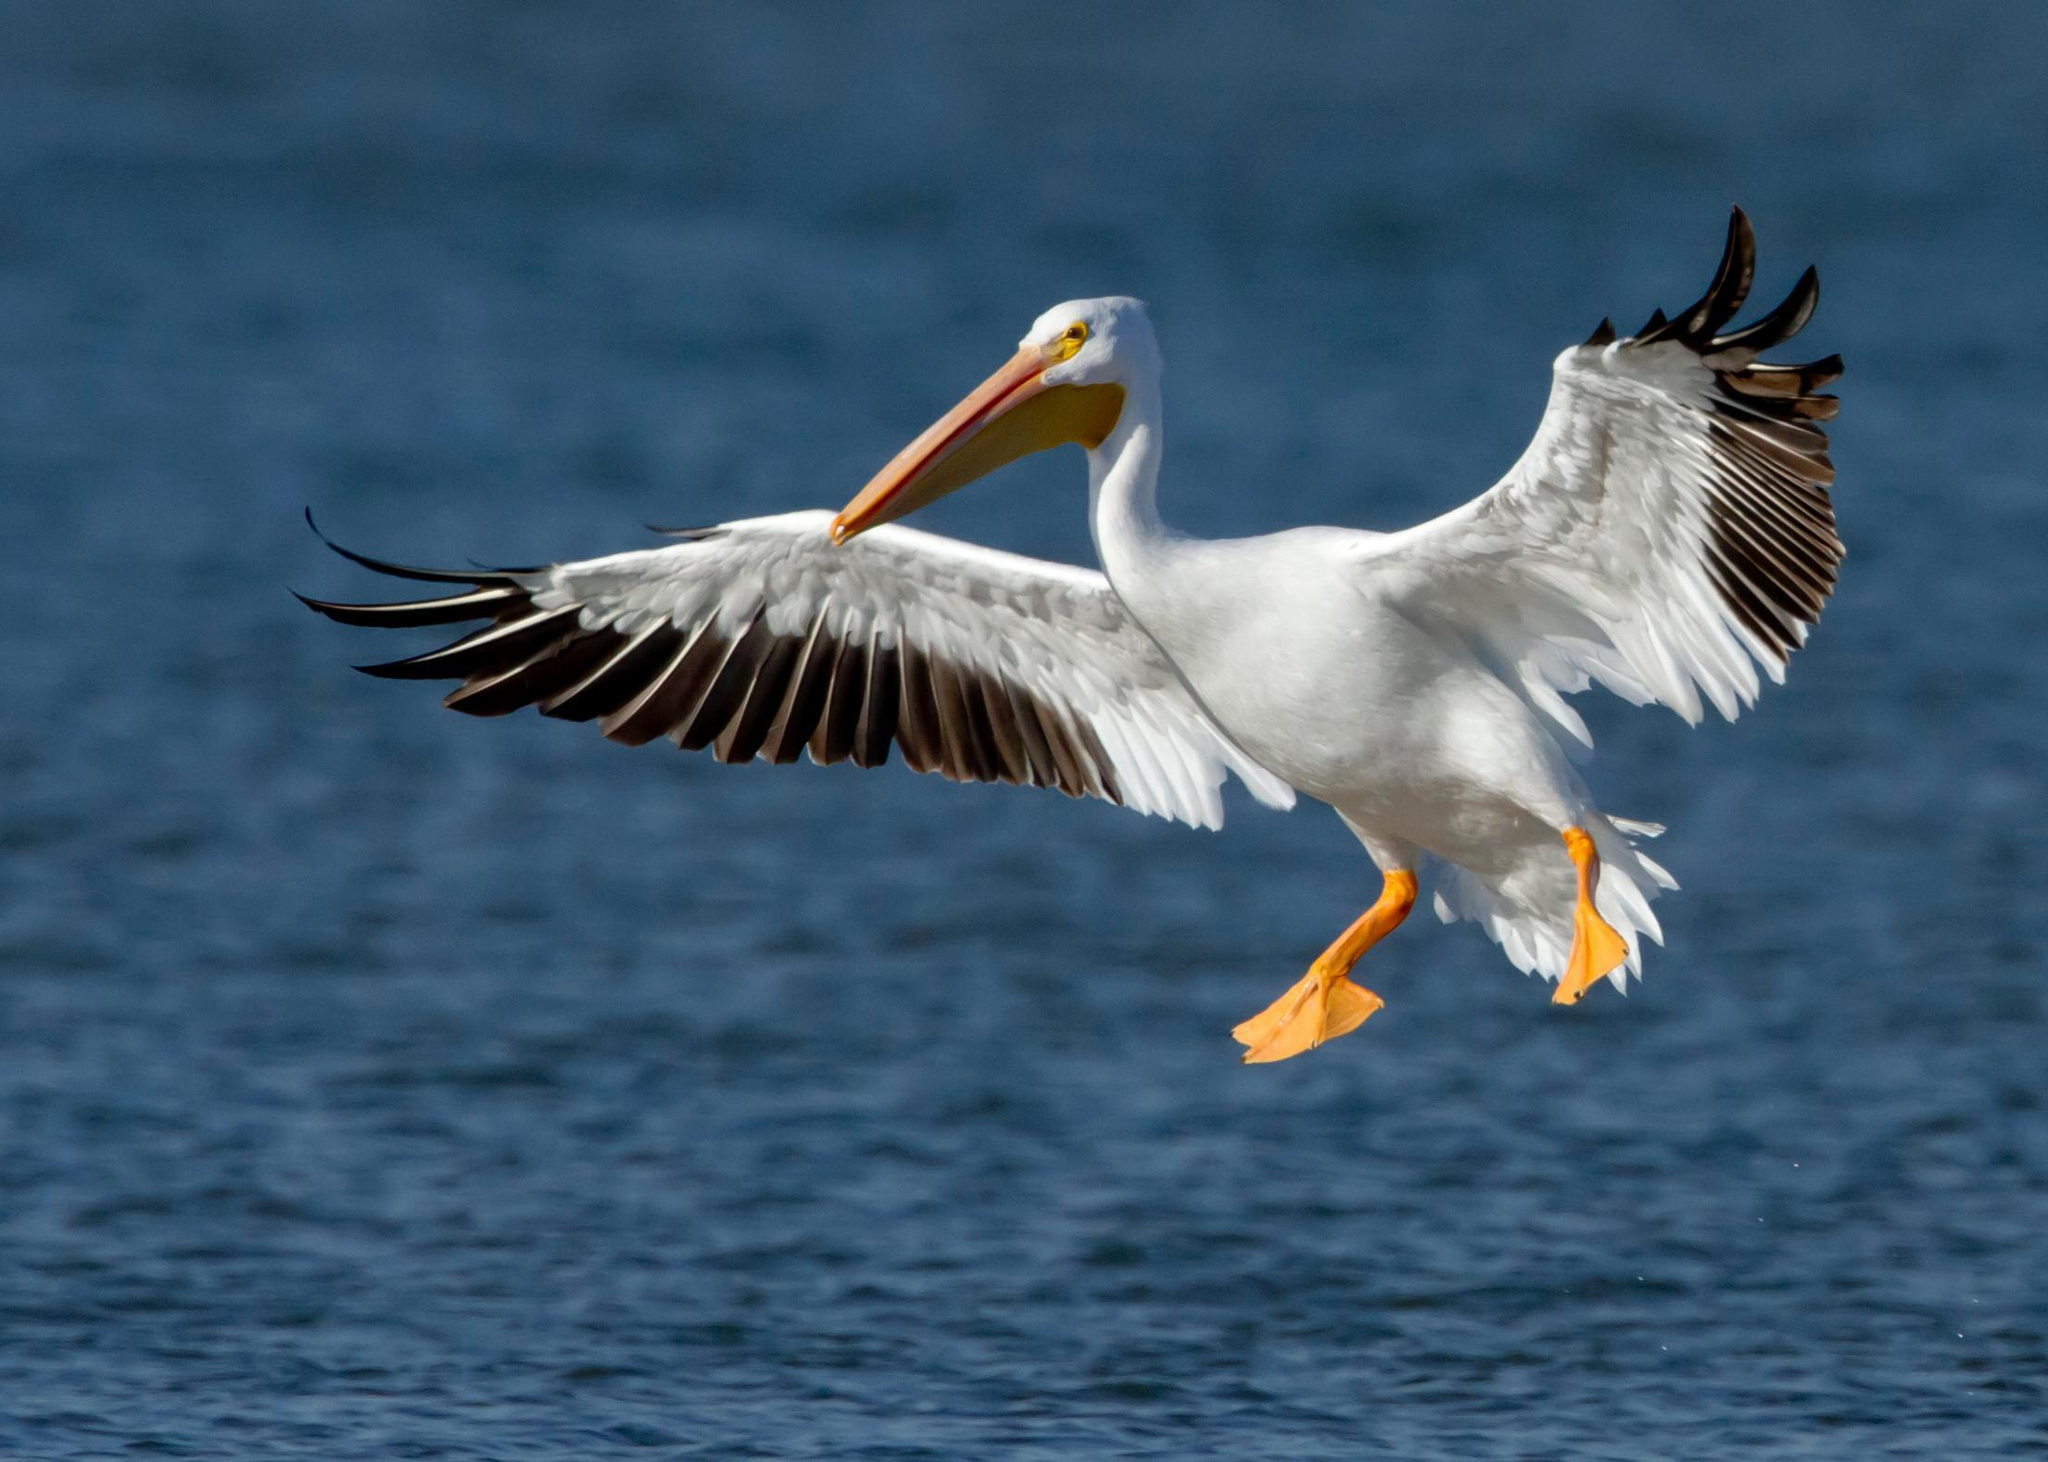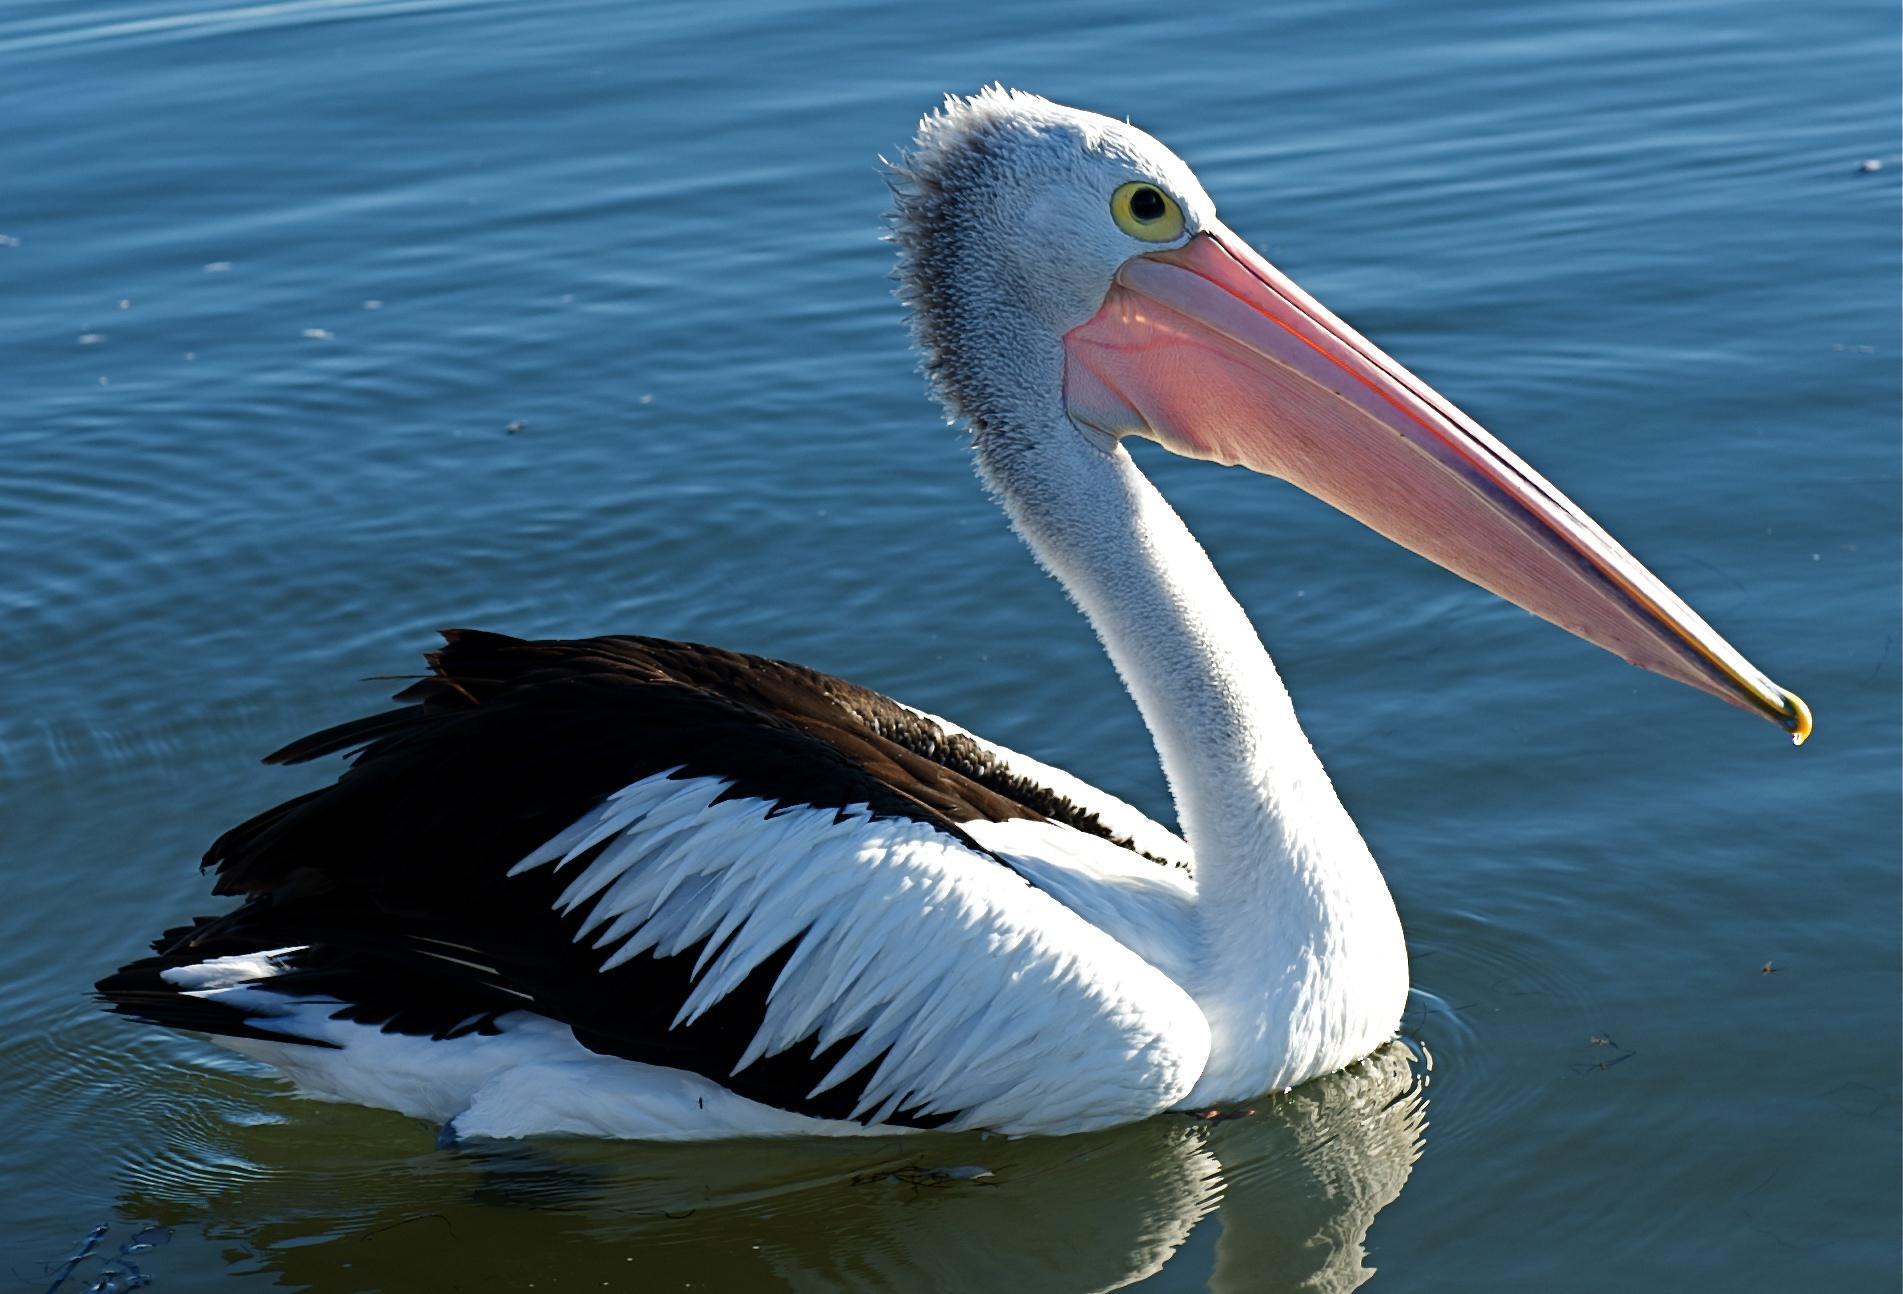The first image is the image on the left, the second image is the image on the right. Evaluate the accuracy of this statement regarding the images: "A bird flies right above the water in the image on the right.". Is it true? Answer yes or no. No. The first image is the image on the left, the second image is the image on the right. Evaluate the accuracy of this statement regarding the images: "A fish is visible in the distended lower bill of a floating pelican with its body facing the camera.". Is it true? Answer yes or no. No. The first image is the image on the left, the second image is the image on the right. Given the left and right images, does the statement "One white-bodied pelican has a closed beak and is in the air above the water with spread wings." hold true? Answer yes or no. Yes. The first image is the image on the left, the second image is the image on the right. Examine the images to the left and right. Is the description "The bird in the image on the right is in flight." accurate? Answer yes or no. No. The first image is the image on the left, the second image is the image on the right. Evaluate the accuracy of this statement regarding the images: "An image shows one white-bodied pelican above blue water, with outstretched wings.". Is it true? Answer yes or no. Yes. The first image is the image on the left, the second image is the image on the right. Analyze the images presented: Is the assertion "One image includes pelicans on a wooden pier, and the other image shows at least one pelican in the water." valid? Answer yes or no. No. The first image is the image on the left, the second image is the image on the right. Evaluate the accuracy of this statement regarding the images: "At least one bird is sitting in water.". Is it true? Answer yes or no. Yes. The first image is the image on the left, the second image is the image on the right. Considering the images on both sides, is "At least one pelican is flying." valid? Answer yes or no. Yes. 